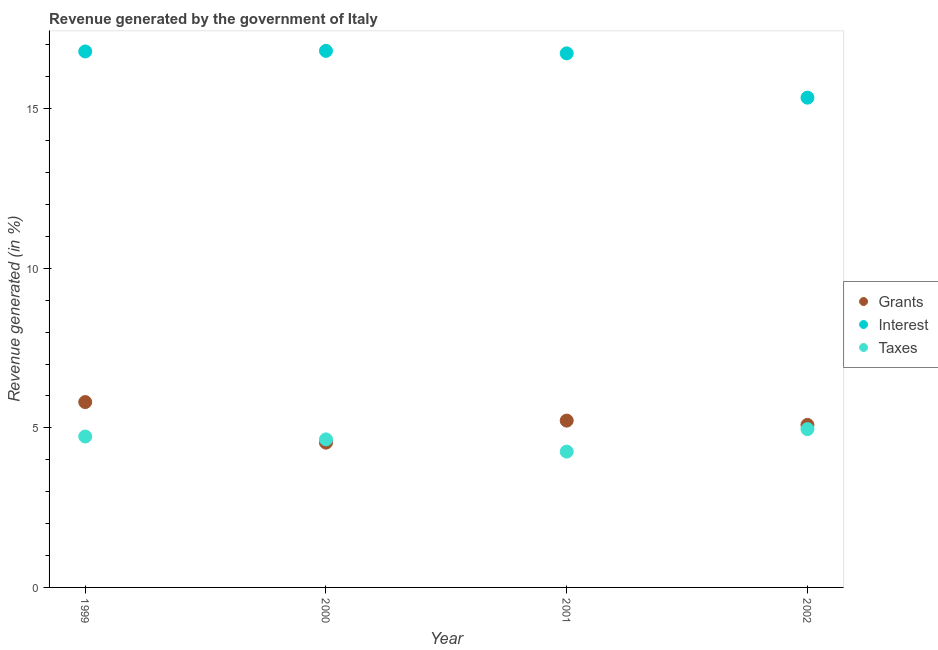How many different coloured dotlines are there?
Your response must be concise. 3. What is the percentage of revenue generated by interest in 1999?
Give a very brief answer. 16.79. Across all years, what is the maximum percentage of revenue generated by taxes?
Give a very brief answer. 4.96. Across all years, what is the minimum percentage of revenue generated by interest?
Offer a terse response. 15.35. What is the total percentage of revenue generated by grants in the graph?
Offer a very short reply. 20.66. What is the difference between the percentage of revenue generated by grants in 2000 and that in 2001?
Make the answer very short. -0.69. What is the difference between the percentage of revenue generated by interest in 1999 and the percentage of revenue generated by grants in 2002?
Give a very brief answer. 11.7. What is the average percentage of revenue generated by interest per year?
Make the answer very short. 16.42. In the year 2002, what is the difference between the percentage of revenue generated by interest and percentage of revenue generated by taxes?
Keep it short and to the point. 10.39. In how many years, is the percentage of revenue generated by taxes greater than 4 %?
Give a very brief answer. 4. What is the ratio of the percentage of revenue generated by grants in 2000 to that in 2002?
Your response must be concise. 0.89. Is the percentage of revenue generated by interest in 1999 less than that in 2000?
Your answer should be very brief. Yes. What is the difference between the highest and the second highest percentage of revenue generated by grants?
Provide a succinct answer. 0.58. What is the difference between the highest and the lowest percentage of revenue generated by grants?
Offer a terse response. 1.27. Does the percentage of revenue generated by interest monotonically increase over the years?
Ensure brevity in your answer.  No. Is the percentage of revenue generated by grants strictly less than the percentage of revenue generated by taxes over the years?
Offer a terse response. No. How many dotlines are there?
Make the answer very short. 3. What is the difference between two consecutive major ticks on the Y-axis?
Ensure brevity in your answer.  5. Are the values on the major ticks of Y-axis written in scientific E-notation?
Provide a succinct answer. No. Where does the legend appear in the graph?
Ensure brevity in your answer.  Center right. What is the title of the graph?
Offer a very short reply. Revenue generated by the government of Italy. Does "Agricultural raw materials" appear as one of the legend labels in the graph?
Offer a terse response. No. What is the label or title of the Y-axis?
Provide a succinct answer. Revenue generated (in %). What is the Revenue generated (in %) of Grants in 1999?
Offer a terse response. 5.81. What is the Revenue generated (in %) of Interest in 1999?
Offer a very short reply. 16.79. What is the Revenue generated (in %) of Taxes in 1999?
Provide a succinct answer. 4.73. What is the Revenue generated (in %) of Grants in 2000?
Provide a short and direct response. 4.54. What is the Revenue generated (in %) in Interest in 2000?
Your answer should be compact. 16.81. What is the Revenue generated (in %) of Taxes in 2000?
Keep it short and to the point. 4.64. What is the Revenue generated (in %) in Grants in 2001?
Ensure brevity in your answer.  5.23. What is the Revenue generated (in %) in Interest in 2001?
Your answer should be compact. 16.73. What is the Revenue generated (in %) in Taxes in 2001?
Your answer should be compact. 4.26. What is the Revenue generated (in %) in Grants in 2002?
Provide a short and direct response. 5.09. What is the Revenue generated (in %) of Interest in 2002?
Keep it short and to the point. 15.35. What is the Revenue generated (in %) in Taxes in 2002?
Your answer should be compact. 4.96. Across all years, what is the maximum Revenue generated (in %) in Grants?
Offer a very short reply. 5.81. Across all years, what is the maximum Revenue generated (in %) in Interest?
Your response must be concise. 16.81. Across all years, what is the maximum Revenue generated (in %) of Taxes?
Provide a short and direct response. 4.96. Across all years, what is the minimum Revenue generated (in %) in Grants?
Provide a succinct answer. 4.54. Across all years, what is the minimum Revenue generated (in %) of Interest?
Provide a short and direct response. 15.35. Across all years, what is the minimum Revenue generated (in %) in Taxes?
Give a very brief answer. 4.26. What is the total Revenue generated (in %) of Grants in the graph?
Give a very brief answer. 20.66. What is the total Revenue generated (in %) of Interest in the graph?
Provide a short and direct response. 65.68. What is the total Revenue generated (in %) of Taxes in the graph?
Ensure brevity in your answer.  18.58. What is the difference between the Revenue generated (in %) in Grants in 1999 and that in 2000?
Offer a very short reply. 1.27. What is the difference between the Revenue generated (in %) in Interest in 1999 and that in 2000?
Make the answer very short. -0.02. What is the difference between the Revenue generated (in %) of Taxes in 1999 and that in 2000?
Provide a short and direct response. 0.09. What is the difference between the Revenue generated (in %) of Grants in 1999 and that in 2001?
Provide a short and direct response. 0.58. What is the difference between the Revenue generated (in %) of Interest in 1999 and that in 2001?
Offer a terse response. 0.06. What is the difference between the Revenue generated (in %) in Taxes in 1999 and that in 2001?
Ensure brevity in your answer.  0.47. What is the difference between the Revenue generated (in %) in Grants in 1999 and that in 2002?
Make the answer very short. 0.72. What is the difference between the Revenue generated (in %) of Interest in 1999 and that in 2002?
Give a very brief answer. 1.45. What is the difference between the Revenue generated (in %) in Taxes in 1999 and that in 2002?
Your answer should be compact. -0.23. What is the difference between the Revenue generated (in %) of Grants in 2000 and that in 2001?
Your response must be concise. -0.69. What is the difference between the Revenue generated (in %) of Interest in 2000 and that in 2001?
Your answer should be very brief. 0.08. What is the difference between the Revenue generated (in %) of Taxes in 2000 and that in 2001?
Give a very brief answer. 0.38. What is the difference between the Revenue generated (in %) of Grants in 2000 and that in 2002?
Keep it short and to the point. -0.55. What is the difference between the Revenue generated (in %) of Interest in 2000 and that in 2002?
Your answer should be very brief. 1.47. What is the difference between the Revenue generated (in %) in Taxes in 2000 and that in 2002?
Your answer should be very brief. -0.32. What is the difference between the Revenue generated (in %) in Grants in 2001 and that in 2002?
Your answer should be compact. 0.14. What is the difference between the Revenue generated (in %) of Interest in 2001 and that in 2002?
Your answer should be compact. 1.39. What is the difference between the Revenue generated (in %) in Taxes in 2001 and that in 2002?
Your response must be concise. -0.7. What is the difference between the Revenue generated (in %) in Grants in 1999 and the Revenue generated (in %) in Interest in 2000?
Offer a very short reply. -11. What is the difference between the Revenue generated (in %) in Grants in 1999 and the Revenue generated (in %) in Taxes in 2000?
Offer a terse response. 1.17. What is the difference between the Revenue generated (in %) of Interest in 1999 and the Revenue generated (in %) of Taxes in 2000?
Your response must be concise. 12.15. What is the difference between the Revenue generated (in %) in Grants in 1999 and the Revenue generated (in %) in Interest in 2001?
Your response must be concise. -10.93. What is the difference between the Revenue generated (in %) in Grants in 1999 and the Revenue generated (in %) in Taxes in 2001?
Ensure brevity in your answer.  1.55. What is the difference between the Revenue generated (in %) in Interest in 1999 and the Revenue generated (in %) in Taxes in 2001?
Keep it short and to the point. 12.54. What is the difference between the Revenue generated (in %) of Grants in 1999 and the Revenue generated (in %) of Interest in 2002?
Offer a very short reply. -9.54. What is the difference between the Revenue generated (in %) in Grants in 1999 and the Revenue generated (in %) in Taxes in 2002?
Offer a very short reply. 0.85. What is the difference between the Revenue generated (in %) of Interest in 1999 and the Revenue generated (in %) of Taxes in 2002?
Make the answer very short. 11.83. What is the difference between the Revenue generated (in %) of Grants in 2000 and the Revenue generated (in %) of Interest in 2001?
Your answer should be compact. -12.2. What is the difference between the Revenue generated (in %) in Grants in 2000 and the Revenue generated (in %) in Taxes in 2001?
Give a very brief answer. 0.28. What is the difference between the Revenue generated (in %) of Interest in 2000 and the Revenue generated (in %) of Taxes in 2001?
Your response must be concise. 12.56. What is the difference between the Revenue generated (in %) in Grants in 2000 and the Revenue generated (in %) in Interest in 2002?
Provide a short and direct response. -10.81. What is the difference between the Revenue generated (in %) in Grants in 2000 and the Revenue generated (in %) in Taxes in 2002?
Your answer should be very brief. -0.42. What is the difference between the Revenue generated (in %) of Interest in 2000 and the Revenue generated (in %) of Taxes in 2002?
Provide a succinct answer. 11.85. What is the difference between the Revenue generated (in %) in Grants in 2001 and the Revenue generated (in %) in Interest in 2002?
Your answer should be very brief. -10.12. What is the difference between the Revenue generated (in %) of Grants in 2001 and the Revenue generated (in %) of Taxes in 2002?
Make the answer very short. 0.27. What is the difference between the Revenue generated (in %) of Interest in 2001 and the Revenue generated (in %) of Taxes in 2002?
Ensure brevity in your answer.  11.77. What is the average Revenue generated (in %) in Grants per year?
Ensure brevity in your answer.  5.17. What is the average Revenue generated (in %) in Interest per year?
Your response must be concise. 16.42. What is the average Revenue generated (in %) in Taxes per year?
Give a very brief answer. 4.65. In the year 1999, what is the difference between the Revenue generated (in %) of Grants and Revenue generated (in %) of Interest?
Your answer should be very brief. -10.99. In the year 1999, what is the difference between the Revenue generated (in %) of Grants and Revenue generated (in %) of Taxes?
Keep it short and to the point. 1.08. In the year 1999, what is the difference between the Revenue generated (in %) in Interest and Revenue generated (in %) in Taxes?
Offer a very short reply. 12.06. In the year 2000, what is the difference between the Revenue generated (in %) in Grants and Revenue generated (in %) in Interest?
Your answer should be very brief. -12.27. In the year 2000, what is the difference between the Revenue generated (in %) in Grants and Revenue generated (in %) in Taxes?
Your answer should be compact. -0.1. In the year 2000, what is the difference between the Revenue generated (in %) of Interest and Revenue generated (in %) of Taxes?
Offer a terse response. 12.17. In the year 2001, what is the difference between the Revenue generated (in %) in Grants and Revenue generated (in %) in Interest?
Offer a very short reply. -11.51. In the year 2001, what is the difference between the Revenue generated (in %) of Grants and Revenue generated (in %) of Taxes?
Ensure brevity in your answer.  0.97. In the year 2001, what is the difference between the Revenue generated (in %) in Interest and Revenue generated (in %) in Taxes?
Your answer should be very brief. 12.48. In the year 2002, what is the difference between the Revenue generated (in %) of Grants and Revenue generated (in %) of Interest?
Your answer should be compact. -10.25. In the year 2002, what is the difference between the Revenue generated (in %) in Grants and Revenue generated (in %) in Taxes?
Offer a very short reply. 0.13. In the year 2002, what is the difference between the Revenue generated (in %) of Interest and Revenue generated (in %) of Taxes?
Provide a succinct answer. 10.39. What is the ratio of the Revenue generated (in %) in Grants in 1999 to that in 2000?
Ensure brevity in your answer.  1.28. What is the ratio of the Revenue generated (in %) in Taxes in 1999 to that in 2000?
Keep it short and to the point. 1.02. What is the ratio of the Revenue generated (in %) of Grants in 1999 to that in 2001?
Make the answer very short. 1.11. What is the ratio of the Revenue generated (in %) of Interest in 1999 to that in 2001?
Keep it short and to the point. 1. What is the ratio of the Revenue generated (in %) of Taxes in 1999 to that in 2001?
Provide a succinct answer. 1.11. What is the ratio of the Revenue generated (in %) in Grants in 1999 to that in 2002?
Offer a very short reply. 1.14. What is the ratio of the Revenue generated (in %) in Interest in 1999 to that in 2002?
Your response must be concise. 1.09. What is the ratio of the Revenue generated (in %) in Taxes in 1999 to that in 2002?
Make the answer very short. 0.95. What is the ratio of the Revenue generated (in %) in Grants in 2000 to that in 2001?
Your answer should be compact. 0.87. What is the ratio of the Revenue generated (in %) in Interest in 2000 to that in 2001?
Offer a very short reply. 1. What is the ratio of the Revenue generated (in %) in Taxes in 2000 to that in 2001?
Keep it short and to the point. 1.09. What is the ratio of the Revenue generated (in %) of Grants in 2000 to that in 2002?
Give a very brief answer. 0.89. What is the ratio of the Revenue generated (in %) of Interest in 2000 to that in 2002?
Provide a succinct answer. 1.1. What is the ratio of the Revenue generated (in %) of Taxes in 2000 to that in 2002?
Provide a succinct answer. 0.94. What is the ratio of the Revenue generated (in %) in Grants in 2001 to that in 2002?
Keep it short and to the point. 1.03. What is the ratio of the Revenue generated (in %) in Interest in 2001 to that in 2002?
Provide a succinct answer. 1.09. What is the ratio of the Revenue generated (in %) in Taxes in 2001 to that in 2002?
Keep it short and to the point. 0.86. What is the difference between the highest and the second highest Revenue generated (in %) of Grants?
Keep it short and to the point. 0.58. What is the difference between the highest and the second highest Revenue generated (in %) of Interest?
Make the answer very short. 0.02. What is the difference between the highest and the second highest Revenue generated (in %) of Taxes?
Make the answer very short. 0.23. What is the difference between the highest and the lowest Revenue generated (in %) of Grants?
Offer a terse response. 1.27. What is the difference between the highest and the lowest Revenue generated (in %) of Interest?
Offer a terse response. 1.47. What is the difference between the highest and the lowest Revenue generated (in %) of Taxes?
Your answer should be very brief. 0.7. 